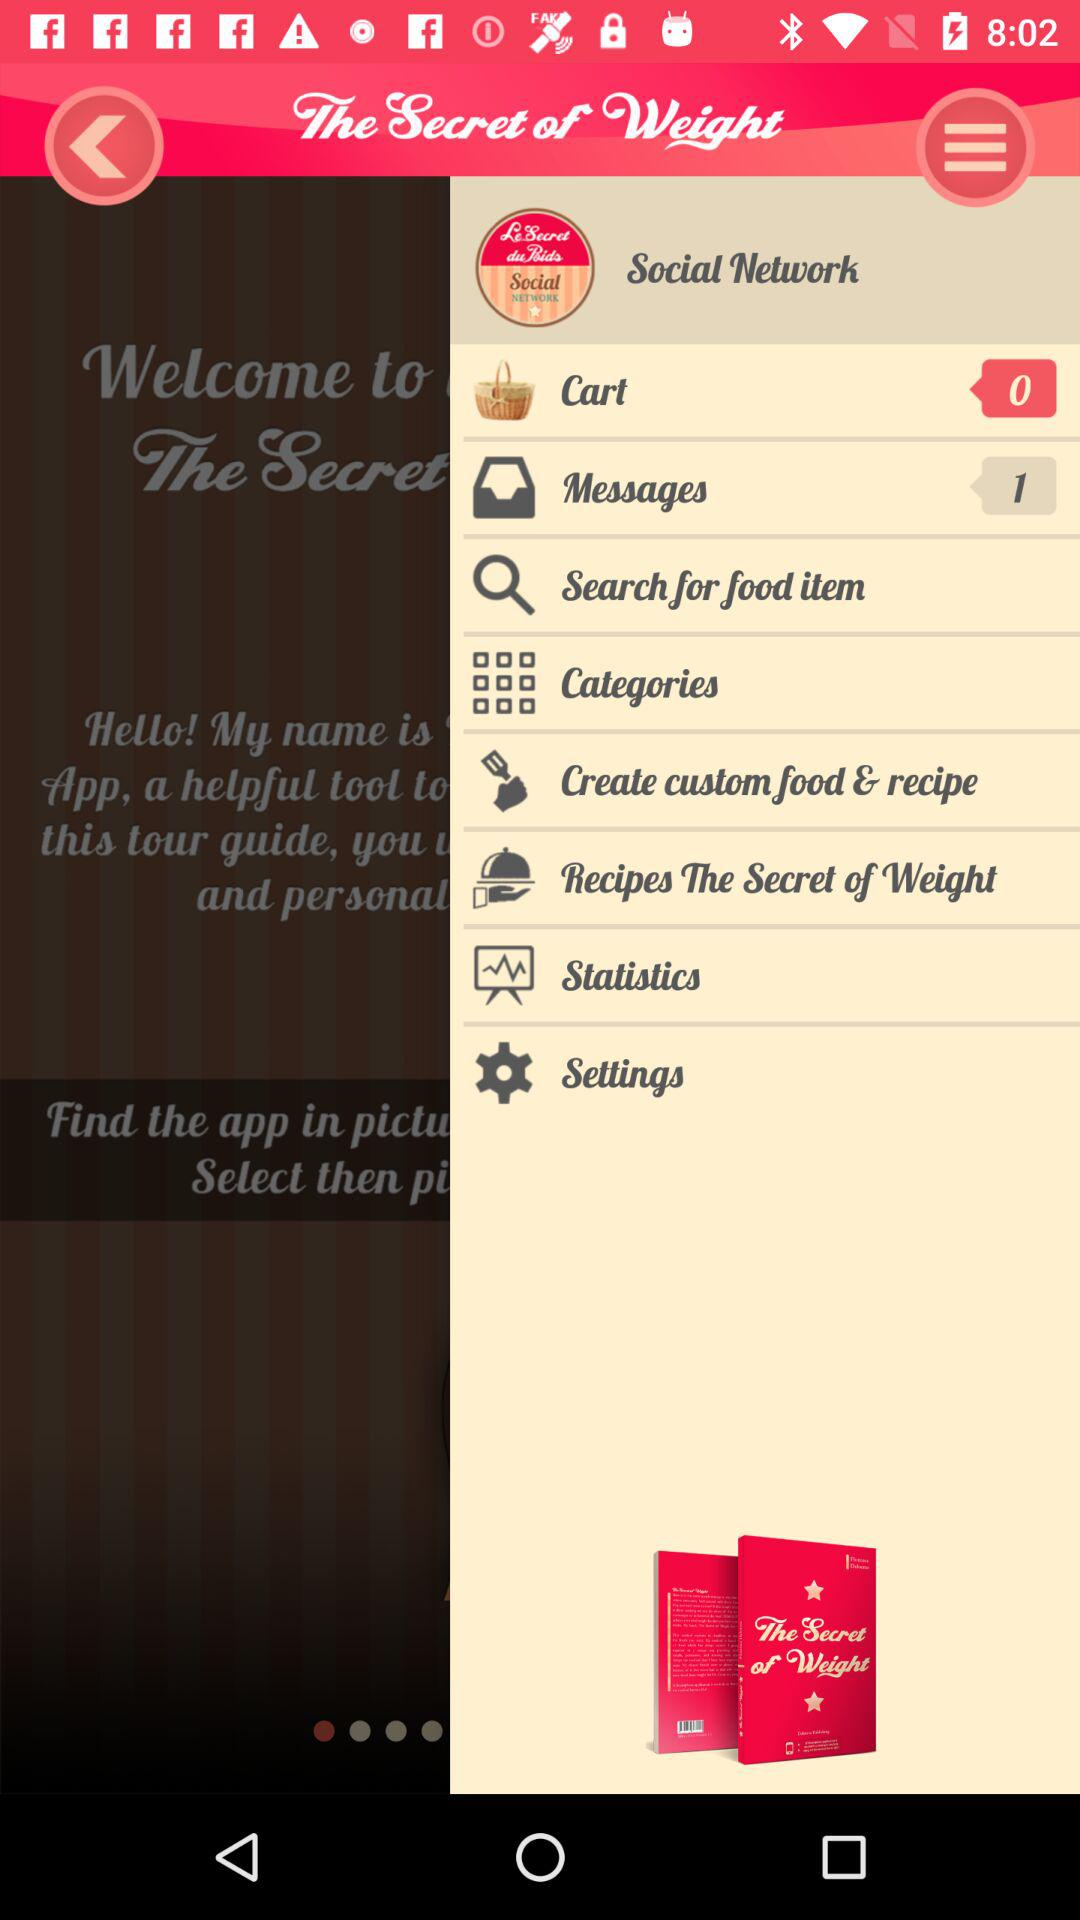What is the application name? The application name is "The Secret of Weight". 